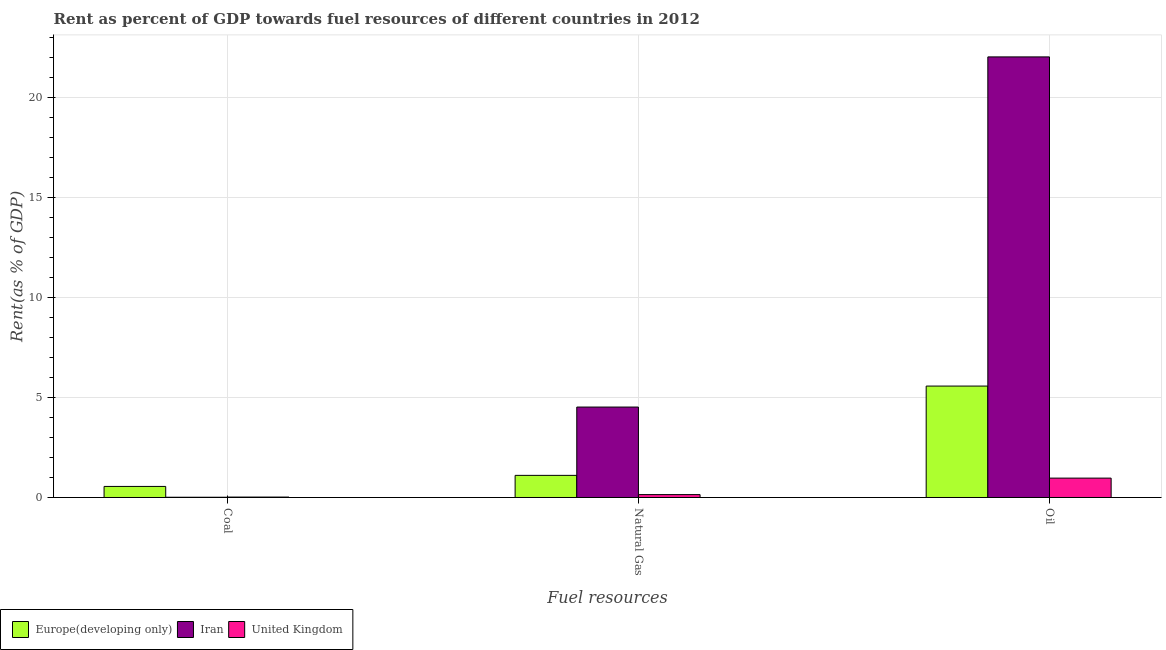How many different coloured bars are there?
Your response must be concise. 3. How many groups of bars are there?
Make the answer very short. 3. What is the label of the 2nd group of bars from the left?
Offer a terse response. Natural Gas. What is the rent towards natural gas in Europe(developing only)?
Make the answer very short. 1.11. Across all countries, what is the maximum rent towards coal?
Your answer should be very brief. 0.55. Across all countries, what is the minimum rent towards natural gas?
Offer a terse response. 0.14. In which country was the rent towards oil maximum?
Keep it short and to the point. Iran. In which country was the rent towards natural gas minimum?
Keep it short and to the point. United Kingdom. What is the total rent towards coal in the graph?
Your response must be concise. 0.59. What is the difference between the rent towards oil in Iran and that in United Kingdom?
Make the answer very short. 21.08. What is the difference between the rent towards natural gas in Iran and the rent towards coal in United Kingdom?
Give a very brief answer. 4.51. What is the average rent towards natural gas per country?
Ensure brevity in your answer.  1.93. What is the difference between the rent towards oil and rent towards natural gas in Iran?
Your response must be concise. 17.53. What is the ratio of the rent towards natural gas in Iran to that in Europe(developing only)?
Your response must be concise. 4.09. Is the rent towards coal in Iran less than that in Europe(developing only)?
Your answer should be very brief. Yes. Is the difference between the rent towards coal in United Kingdom and Iran greater than the difference between the rent towards oil in United Kingdom and Iran?
Ensure brevity in your answer.  Yes. What is the difference between the highest and the second highest rent towards oil?
Keep it short and to the point. 16.48. What is the difference between the highest and the lowest rent towards natural gas?
Your answer should be compact. 4.38. In how many countries, is the rent towards coal greater than the average rent towards coal taken over all countries?
Give a very brief answer. 1. What does the 1st bar from the left in Coal represents?
Provide a short and direct response. Europe(developing only). What does the 2nd bar from the right in Natural Gas represents?
Your answer should be compact. Iran. Is it the case that in every country, the sum of the rent towards coal and rent towards natural gas is greater than the rent towards oil?
Provide a short and direct response. No. How many bars are there?
Offer a very short reply. 9. What is the difference between two consecutive major ticks on the Y-axis?
Your answer should be compact. 5. Are the values on the major ticks of Y-axis written in scientific E-notation?
Your answer should be compact. No. Does the graph contain any zero values?
Your answer should be compact. No. Where does the legend appear in the graph?
Provide a short and direct response. Bottom left. How are the legend labels stacked?
Your answer should be very brief. Horizontal. What is the title of the graph?
Make the answer very short. Rent as percent of GDP towards fuel resources of different countries in 2012. What is the label or title of the X-axis?
Keep it short and to the point. Fuel resources. What is the label or title of the Y-axis?
Provide a succinct answer. Rent(as % of GDP). What is the Rent(as % of GDP) of Europe(developing only) in Coal?
Your answer should be very brief. 0.55. What is the Rent(as % of GDP) in Iran in Coal?
Ensure brevity in your answer.  0.01. What is the Rent(as % of GDP) in United Kingdom in Coal?
Ensure brevity in your answer.  0.02. What is the Rent(as % of GDP) in Europe(developing only) in Natural Gas?
Offer a terse response. 1.11. What is the Rent(as % of GDP) of Iran in Natural Gas?
Your response must be concise. 4.53. What is the Rent(as % of GDP) of United Kingdom in Natural Gas?
Give a very brief answer. 0.14. What is the Rent(as % of GDP) in Europe(developing only) in Oil?
Give a very brief answer. 5.58. What is the Rent(as % of GDP) in Iran in Oil?
Your answer should be very brief. 22.05. What is the Rent(as % of GDP) in United Kingdom in Oil?
Keep it short and to the point. 0.97. Across all Fuel resources, what is the maximum Rent(as % of GDP) in Europe(developing only)?
Provide a succinct answer. 5.58. Across all Fuel resources, what is the maximum Rent(as % of GDP) in Iran?
Your answer should be very brief. 22.05. Across all Fuel resources, what is the maximum Rent(as % of GDP) of United Kingdom?
Ensure brevity in your answer.  0.97. Across all Fuel resources, what is the minimum Rent(as % of GDP) of Europe(developing only)?
Provide a succinct answer. 0.55. Across all Fuel resources, what is the minimum Rent(as % of GDP) of Iran?
Give a very brief answer. 0.01. Across all Fuel resources, what is the minimum Rent(as % of GDP) in United Kingdom?
Make the answer very short. 0.02. What is the total Rent(as % of GDP) in Europe(developing only) in the graph?
Offer a terse response. 7.24. What is the total Rent(as % of GDP) of Iran in the graph?
Offer a very short reply. 26.59. What is the total Rent(as % of GDP) of United Kingdom in the graph?
Provide a short and direct response. 1.14. What is the difference between the Rent(as % of GDP) in Europe(developing only) in Coal and that in Natural Gas?
Provide a succinct answer. -0.55. What is the difference between the Rent(as % of GDP) in Iran in Coal and that in Natural Gas?
Provide a short and direct response. -4.51. What is the difference between the Rent(as % of GDP) in United Kingdom in Coal and that in Natural Gas?
Keep it short and to the point. -0.12. What is the difference between the Rent(as % of GDP) in Europe(developing only) in Coal and that in Oil?
Make the answer very short. -5.02. What is the difference between the Rent(as % of GDP) of Iran in Coal and that in Oil?
Ensure brevity in your answer.  -22.04. What is the difference between the Rent(as % of GDP) in United Kingdom in Coal and that in Oil?
Your answer should be very brief. -0.95. What is the difference between the Rent(as % of GDP) in Europe(developing only) in Natural Gas and that in Oil?
Ensure brevity in your answer.  -4.47. What is the difference between the Rent(as % of GDP) in Iran in Natural Gas and that in Oil?
Offer a terse response. -17.53. What is the difference between the Rent(as % of GDP) of United Kingdom in Natural Gas and that in Oil?
Give a very brief answer. -0.82. What is the difference between the Rent(as % of GDP) of Europe(developing only) in Coal and the Rent(as % of GDP) of Iran in Natural Gas?
Offer a very short reply. -3.97. What is the difference between the Rent(as % of GDP) in Europe(developing only) in Coal and the Rent(as % of GDP) in United Kingdom in Natural Gas?
Your answer should be very brief. 0.41. What is the difference between the Rent(as % of GDP) of Iran in Coal and the Rent(as % of GDP) of United Kingdom in Natural Gas?
Make the answer very short. -0.13. What is the difference between the Rent(as % of GDP) of Europe(developing only) in Coal and the Rent(as % of GDP) of Iran in Oil?
Ensure brevity in your answer.  -21.5. What is the difference between the Rent(as % of GDP) in Europe(developing only) in Coal and the Rent(as % of GDP) in United Kingdom in Oil?
Provide a short and direct response. -0.42. What is the difference between the Rent(as % of GDP) of Iran in Coal and the Rent(as % of GDP) of United Kingdom in Oil?
Provide a succinct answer. -0.96. What is the difference between the Rent(as % of GDP) of Europe(developing only) in Natural Gas and the Rent(as % of GDP) of Iran in Oil?
Keep it short and to the point. -20.95. What is the difference between the Rent(as % of GDP) in Europe(developing only) in Natural Gas and the Rent(as % of GDP) in United Kingdom in Oil?
Provide a short and direct response. 0.14. What is the difference between the Rent(as % of GDP) in Iran in Natural Gas and the Rent(as % of GDP) in United Kingdom in Oil?
Keep it short and to the point. 3.56. What is the average Rent(as % of GDP) in Europe(developing only) per Fuel resources?
Your answer should be compact. 2.41. What is the average Rent(as % of GDP) in Iran per Fuel resources?
Your response must be concise. 8.86. What is the average Rent(as % of GDP) of United Kingdom per Fuel resources?
Keep it short and to the point. 0.38. What is the difference between the Rent(as % of GDP) in Europe(developing only) and Rent(as % of GDP) in Iran in Coal?
Offer a very short reply. 0.54. What is the difference between the Rent(as % of GDP) of Europe(developing only) and Rent(as % of GDP) of United Kingdom in Coal?
Your answer should be very brief. 0.53. What is the difference between the Rent(as % of GDP) of Iran and Rent(as % of GDP) of United Kingdom in Coal?
Give a very brief answer. -0.01. What is the difference between the Rent(as % of GDP) of Europe(developing only) and Rent(as % of GDP) of Iran in Natural Gas?
Your answer should be very brief. -3.42. What is the difference between the Rent(as % of GDP) in Europe(developing only) and Rent(as % of GDP) in United Kingdom in Natural Gas?
Give a very brief answer. 0.96. What is the difference between the Rent(as % of GDP) of Iran and Rent(as % of GDP) of United Kingdom in Natural Gas?
Offer a terse response. 4.38. What is the difference between the Rent(as % of GDP) of Europe(developing only) and Rent(as % of GDP) of Iran in Oil?
Offer a terse response. -16.48. What is the difference between the Rent(as % of GDP) in Europe(developing only) and Rent(as % of GDP) in United Kingdom in Oil?
Offer a terse response. 4.61. What is the difference between the Rent(as % of GDP) of Iran and Rent(as % of GDP) of United Kingdom in Oil?
Ensure brevity in your answer.  21.08. What is the ratio of the Rent(as % of GDP) of Europe(developing only) in Coal to that in Natural Gas?
Provide a short and direct response. 0.5. What is the ratio of the Rent(as % of GDP) of Iran in Coal to that in Natural Gas?
Provide a short and direct response. 0. What is the ratio of the Rent(as % of GDP) in United Kingdom in Coal to that in Natural Gas?
Ensure brevity in your answer.  0.15. What is the ratio of the Rent(as % of GDP) in Europe(developing only) in Coal to that in Oil?
Your answer should be compact. 0.1. What is the ratio of the Rent(as % of GDP) of United Kingdom in Coal to that in Oil?
Offer a very short reply. 0.02. What is the ratio of the Rent(as % of GDP) in Europe(developing only) in Natural Gas to that in Oil?
Provide a short and direct response. 0.2. What is the ratio of the Rent(as % of GDP) in Iran in Natural Gas to that in Oil?
Your response must be concise. 0.21. What is the ratio of the Rent(as % of GDP) of United Kingdom in Natural Gas to that in Oil?
Give a very brief answer. 0.15. What is the difference between the highest and the second highest Rent(as % of GDP) of Europe(developing only)?
Keep it short and to the point. 4.47. What is the difference between the highest and the second highest Rent(as % of GDP) of Iran?
Give a very brief answer. 17.53. What is the difference between the highest and the second highest Rent(as % of GDP) of United Kingdom?
Your response must be concise. 0.82. What is the difference between the highest and the lowest Rent(as % of GDP) in Europe(developing only)?
Provide a short and direct response. 5.02. What is the difference between the highest and the lowest Rent(as % of GDP) in Iran?
Give a very brief answer. 22.04. What is the difference between the highest and the lowest Rent(as % of GDP) of United Kingdom?
Give a very brief answer. 0.95. 